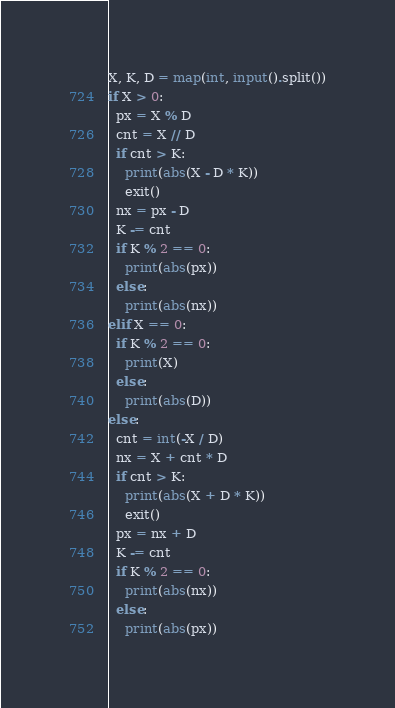<code> <loc_0><loc_0><loc_500><loc_500><_Python_>X, K, D = map(int, input().split())
if X > 0:
  px = X % D
  cnt = X // D
  if cnt > K:
    print(abs(X - D * K))
    exit()
  nx = px - D
  K -= cnt
  if K % 2 == 0:
    print(abs(px))
  else:
    print(abs(nx))
elif X == 0:
  if K % 2 == 0:
    print(X)
  else:
    print(abs(D))
else:
  cnt = int(-X / D)
  nx = X + cnt * D
  if cnt > K:
    print(abs(X + D * K))
    exit()
  px = nx + D
  K -= cnt
  if K % 2 == 0:
    print(abs(nx))
  else:
    print(abs(px))</code> 